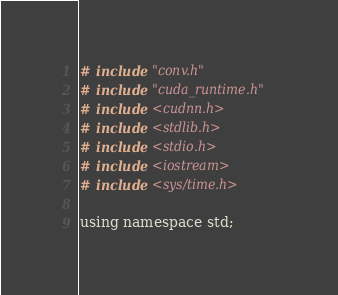Convert code to text. <code><loc_0><loc_0><loc_500><loc_500><_Cuda_># include "conv.h"
# include "cuda_runtime.h"
# include <cudnn.h>
# include <stdlib.h>
# include <stdio.h>
# include <iostream>
# include <sys/time.h>

using namespace std;
</code> 